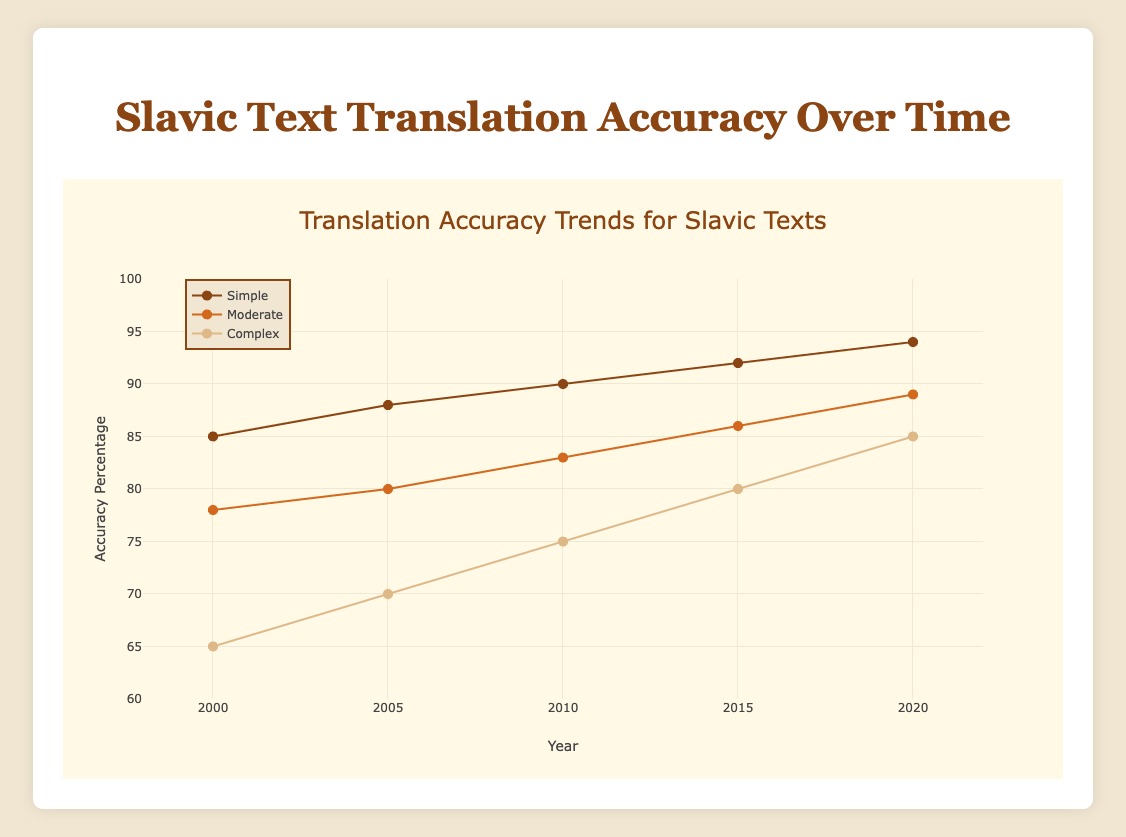What is the title of the scatter plot? The title of the scatter plot is usually found at the top of the figure. It is meant to give a brief description of what the figure is about. Here, the title is "Translation Accuracy Trends for Slavic Texts".
Answer: Translation Accuracy Trends for Slavic Texts What are the three complexities represented in the plot? The complexities are indicated by the legend, which lists different categories and their respective markers. The complexities represented in this plot are "simple", "moderate", and "complex".
Answer: Simple, Moderate, Complex How has the translation accuracy for simple texts changed from 2000 to 2020? To determine this, observe the y-values of the data points for "simple" texts at the years 2000 and 2020. In 2000, the accuracy percentage was 85%, and in 2020, it increased to 94%.
Answer: Increased from 85% to 94% Which year shows the highest translation accuracy for complex texts? By looking at the trend line and data points for complex texts, you can identify the y-value (accuracy percentage) and the corresponding x-value (year). The highest accuracy for complex texts is in the year 2020.
Answer: 2020 What is the overall trend in translation accuracy for moderate texts? To identify the trend, observe the direction of the data points connected by the markers from 2000 to 2020. The accuracy percentage for moderate texts has generally increased over time.
Answer: Increase In the year 2010, how much higher is the accuracy percentage for simple texts compared to complex texts? To find this, subtract the accuracy percentage for complex texts (75%) from that of simple texts (90%) for the year 2010. The difference is 90% - 75% = 15%.
Answer: 15% Which complexity has the most significant improvement in accuracy from 2000 to 2020? Calculate the increase in accuracy for each complexity by subtracting the 2000 accuracy from the 2020 accuracy: Simple: 94% - 85% = 9%, Moderate: 89% - 78% = 11%, Complex: 85% - 65% = 20%. The complex texts saw the most significant improvement.
Answer: Complex texts Comparing the accuracy trends for moderate and simple texts, which complexity achieves a higher accuracy percentage first? By looking at the data trends, you can determine that simple texts consistently have higher accuracy percentages compared to moderate texts throughout the entire timeline from 2000 to 2020. Hence, simple texts achieve higher accuracy first.
Answer: Simple texts For which complexity does the accuracy percentage in 2015 equal the accuracy percentage for complex texts in 2020? Note the accuracy percentage for complex texts in 2020, which is 85%. Then, look at the y-values of other complexities in 2015. The accuracy percentage for complex texts in 2020 (85%) matches that of complex texts in 2015.
Answer: Complex texts Based on the plot, what is the expected trend if the translation accuracy continues to develop similarly beyond 2020? From the trend lines and consistent increases over time for all complexities, it is expected that the translation accuracy for all complexities will continue to improve beyond 2020 if the current trend holds.
Answer: Improvement expected 